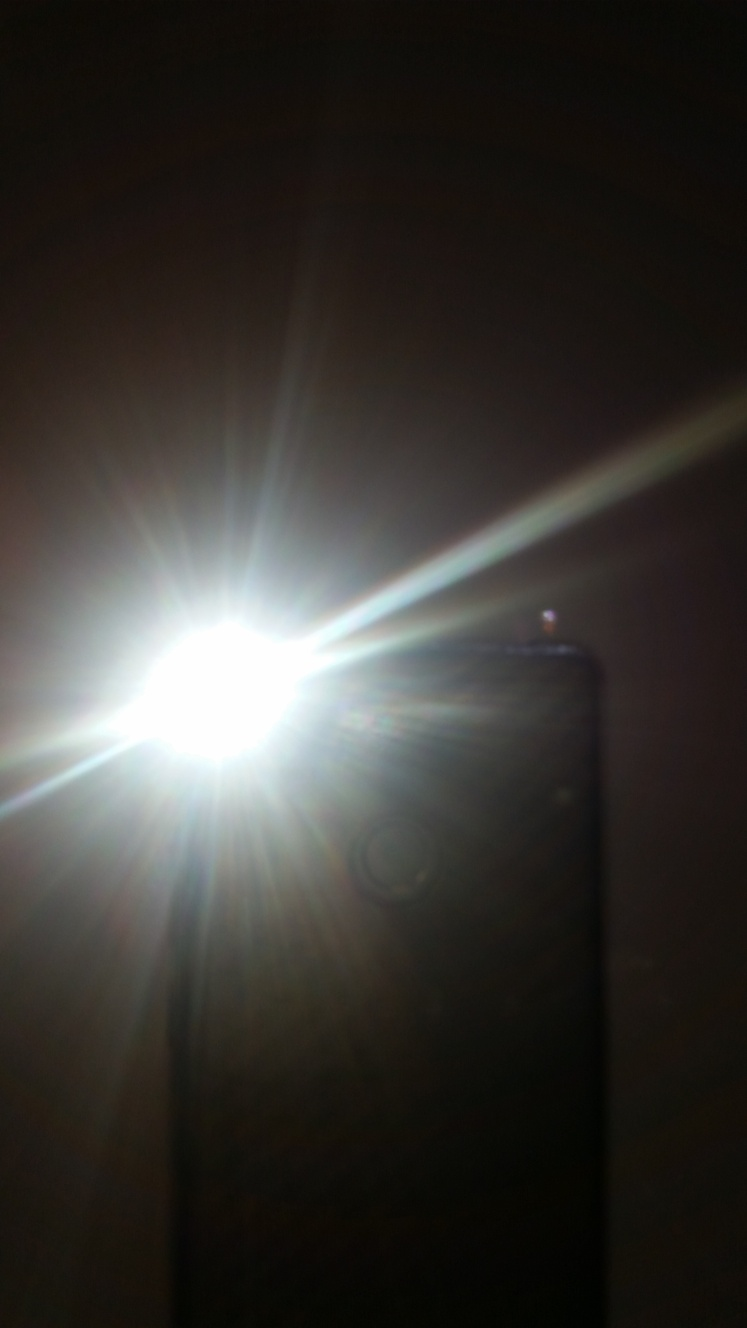What steps should be taken to prevent overexposure in photographs? To prevent overexposure in photography, one should adjust the camera settings to limit light intake. This can be done by using a faster shutter speed, a smaller aperture, or a lower ISO setting. Additionally, using a neutral density filter can be effective in managing excessive light. 